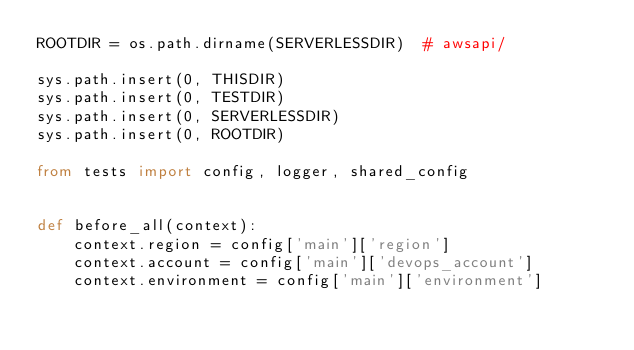<code> <loc_0><loc_0><loc_500><loc_500><_Python_>ROOTDIR = os.path.dirname(SERVERLESSDIR)  # awsapi/

sys.path.insert(0, THISDIR)
sys.path.insert(0, TESTDIR)
sys.path.insert(0, SERVERLESSDIR)
sys.path.insert(0, ROOTDIR)

from tests import config, logger, shared_config


def before_all(context):
    context.region = config['main']['region']
    context.account = config['main']['devops_account']
    context.environment = config['main']['environment']
</code> 